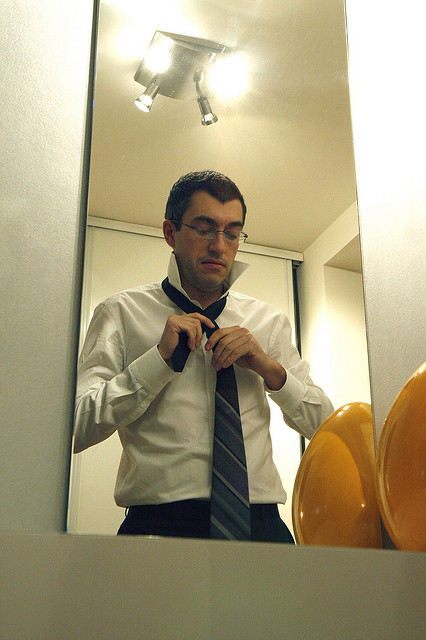Can you count the number of lightbulbs present? Yes, the image shows five lightbulbs. They are strategically positioned to illuminate the area where the man is standing, creating a well-lit environment for his preparation. 